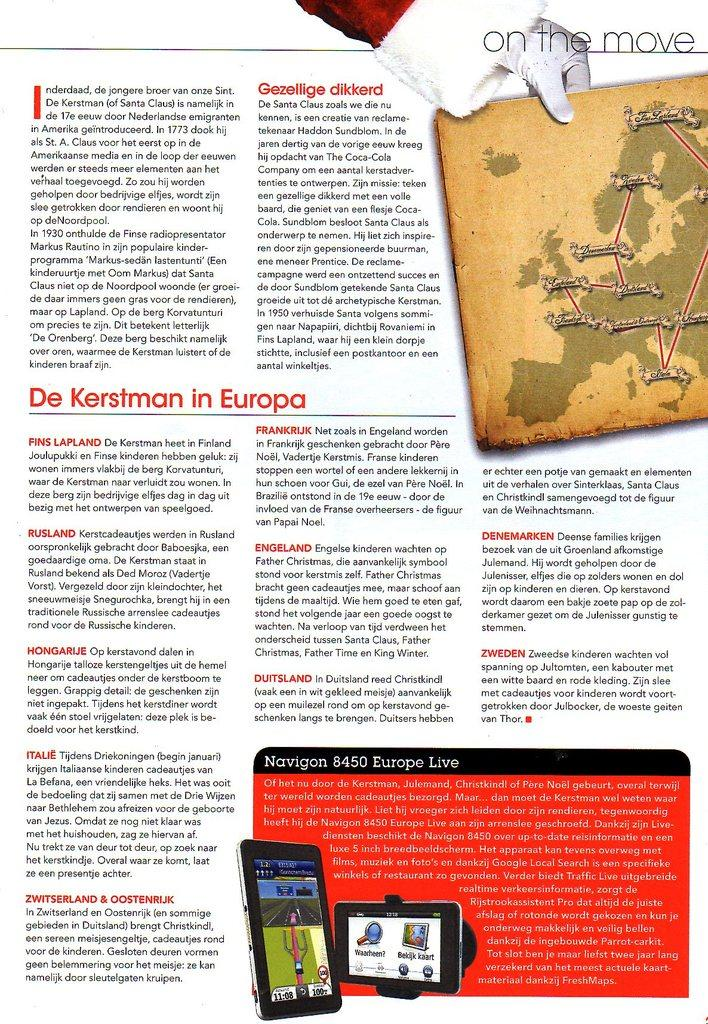<image>
Give a short and clear explanation of the subsequent image. A page from a magazine, the title of the page is "On the move." 